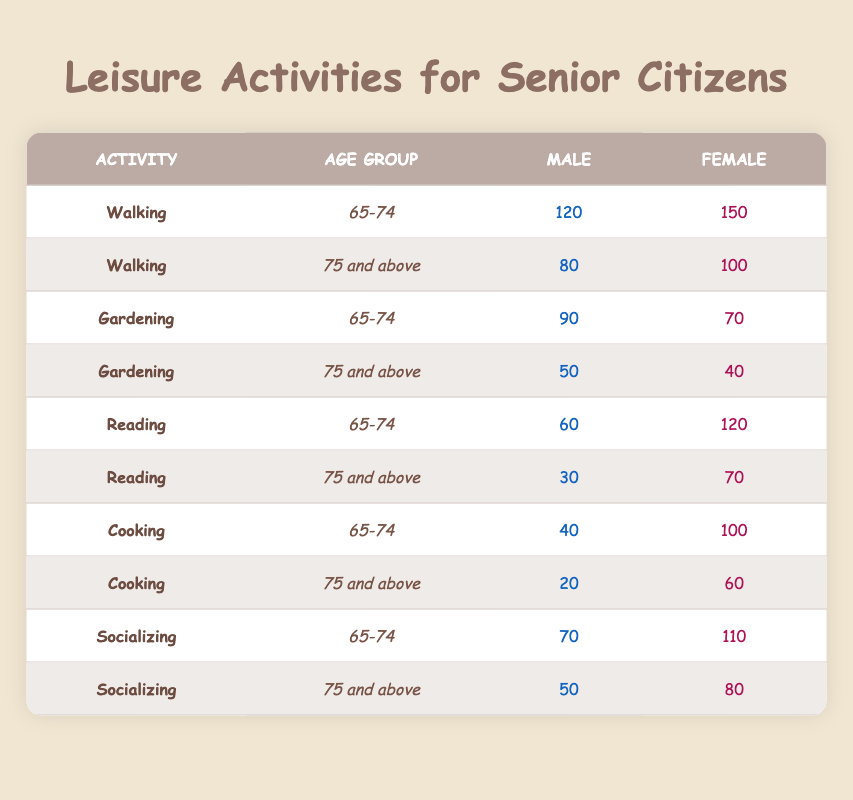What is the total number of females aged 65-74 who enjoy reading? In the table, the number of females aged 65-74 who enjoy reading is given as 120. Therefore, the total number is simply 120.
Answer: 120 How many males aged 75 and above are interested in gardening? From the table, it shows that the number of males aged 75 and above who enjoy gardening is 50.
Answer: 50 Which leisure activity has the highest participation among females aged 65-74? By checking the values for females aged 65-74 across all activities, the highest number is for walking (150). Thus, walking has the highest participation.
Answer: Walking What is the difference in the number of males aged 65-74 participating in walking and socializing? For males aged 65-74, walking has 120 participants and socializing has 70. The difference is 120 - 70 = 50.
Answer: 50 Is reading a more popular activity among females than males in the age group 75 and above? In the age group of 75 and above, females participating in reading is 70 and males is 30. Since 70 is greater than 30, reading is indeed more popular among females.
Answer: Yes What is the total number of participants for socializing across both age groups? For socializing, there are 70 participants in the 65-74 age group (male) and 110 (female), and 50 participants (male) and 80 (female) in the 75 and above age group. Therefore, the total is (70 + 110) + (50 + 80) = 410.
Answer: 410 How many more females than males participate in cooking for the age group 65-74? The table shows 100 females and 40 males in cooking for the 65-74 age group. The difference is 100 - 40 = 60.
Answer: 60 What leisure activity has the lowest number of participants among males aged 75 and above? The table shows that males aged 75 and above have 20 participants in cooking, which is the lowest compared to gardening (50), walking (80), and socializing (50).
Answer: Cooking 